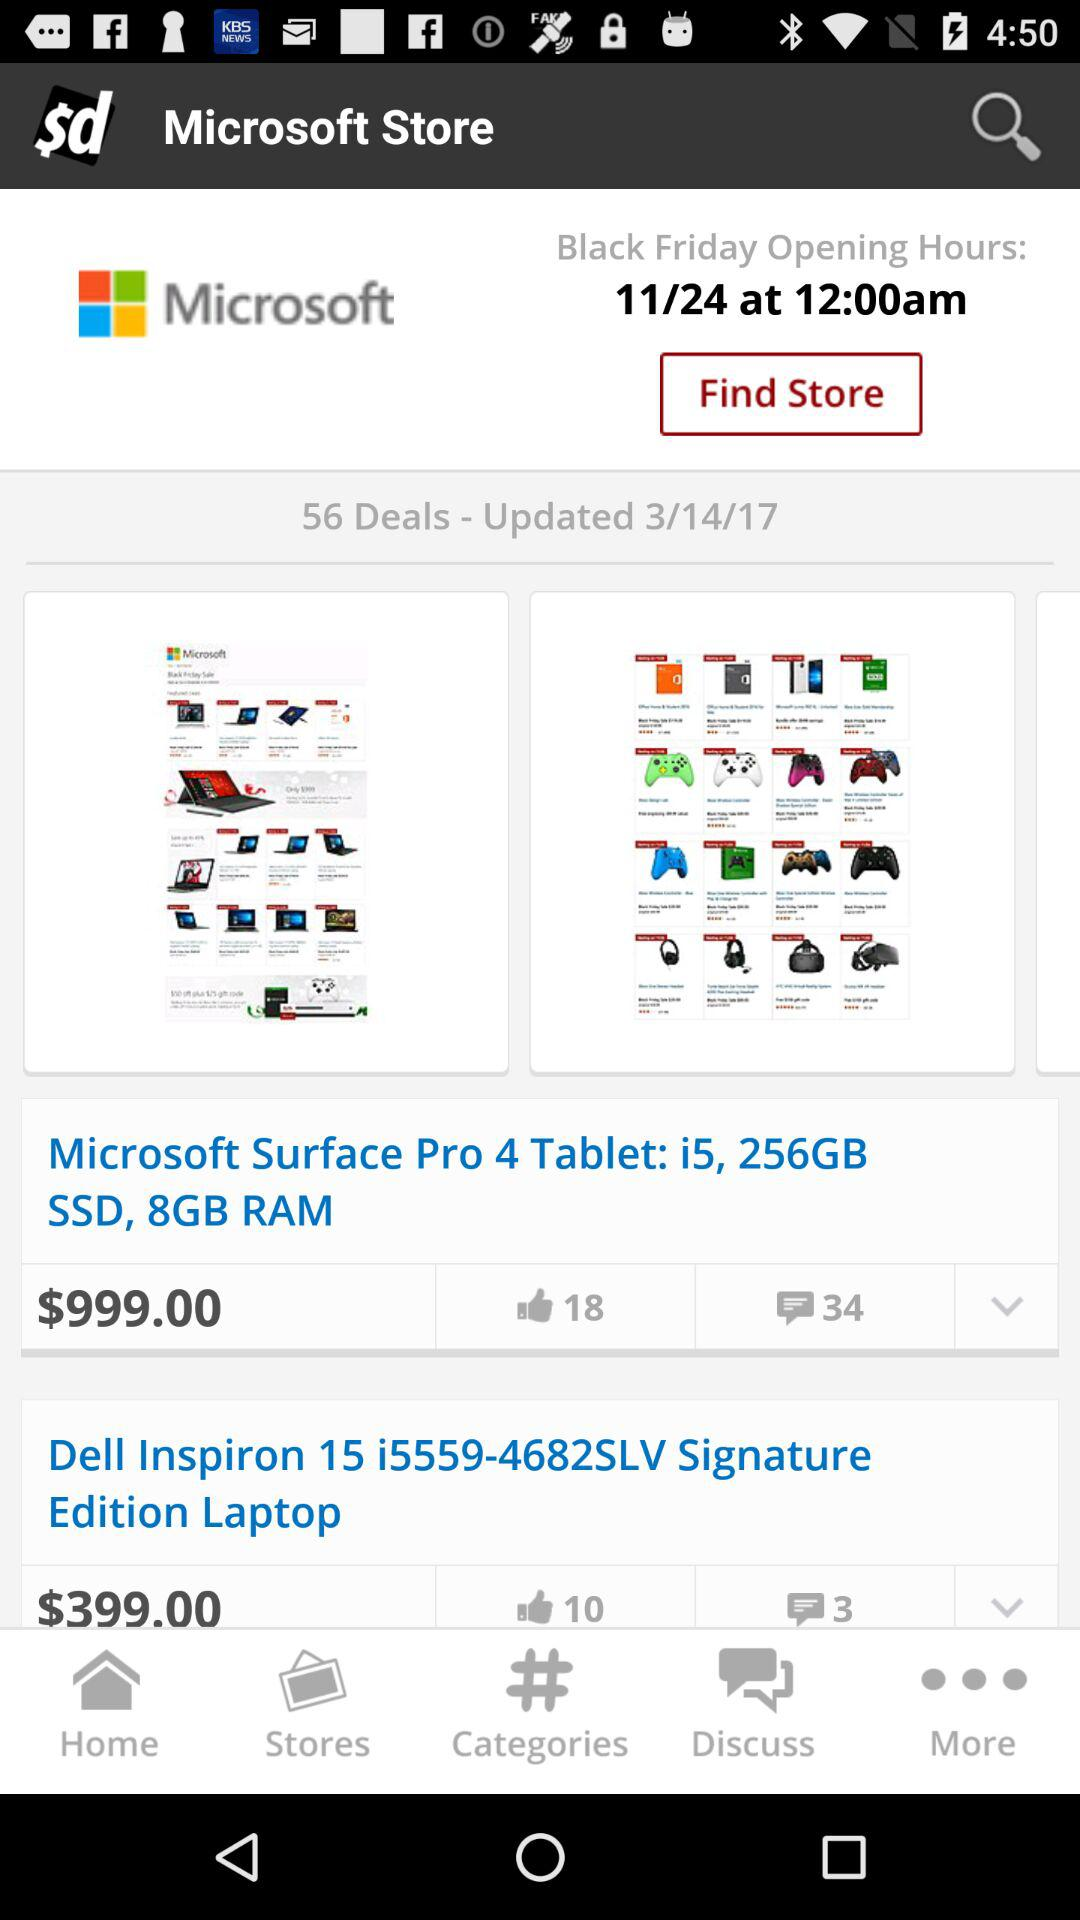How much more expensive is the Microsoft Surface Pro 4 than the Dell Inspiron 15?
Answer the question using a single word or phrase. $600.00 